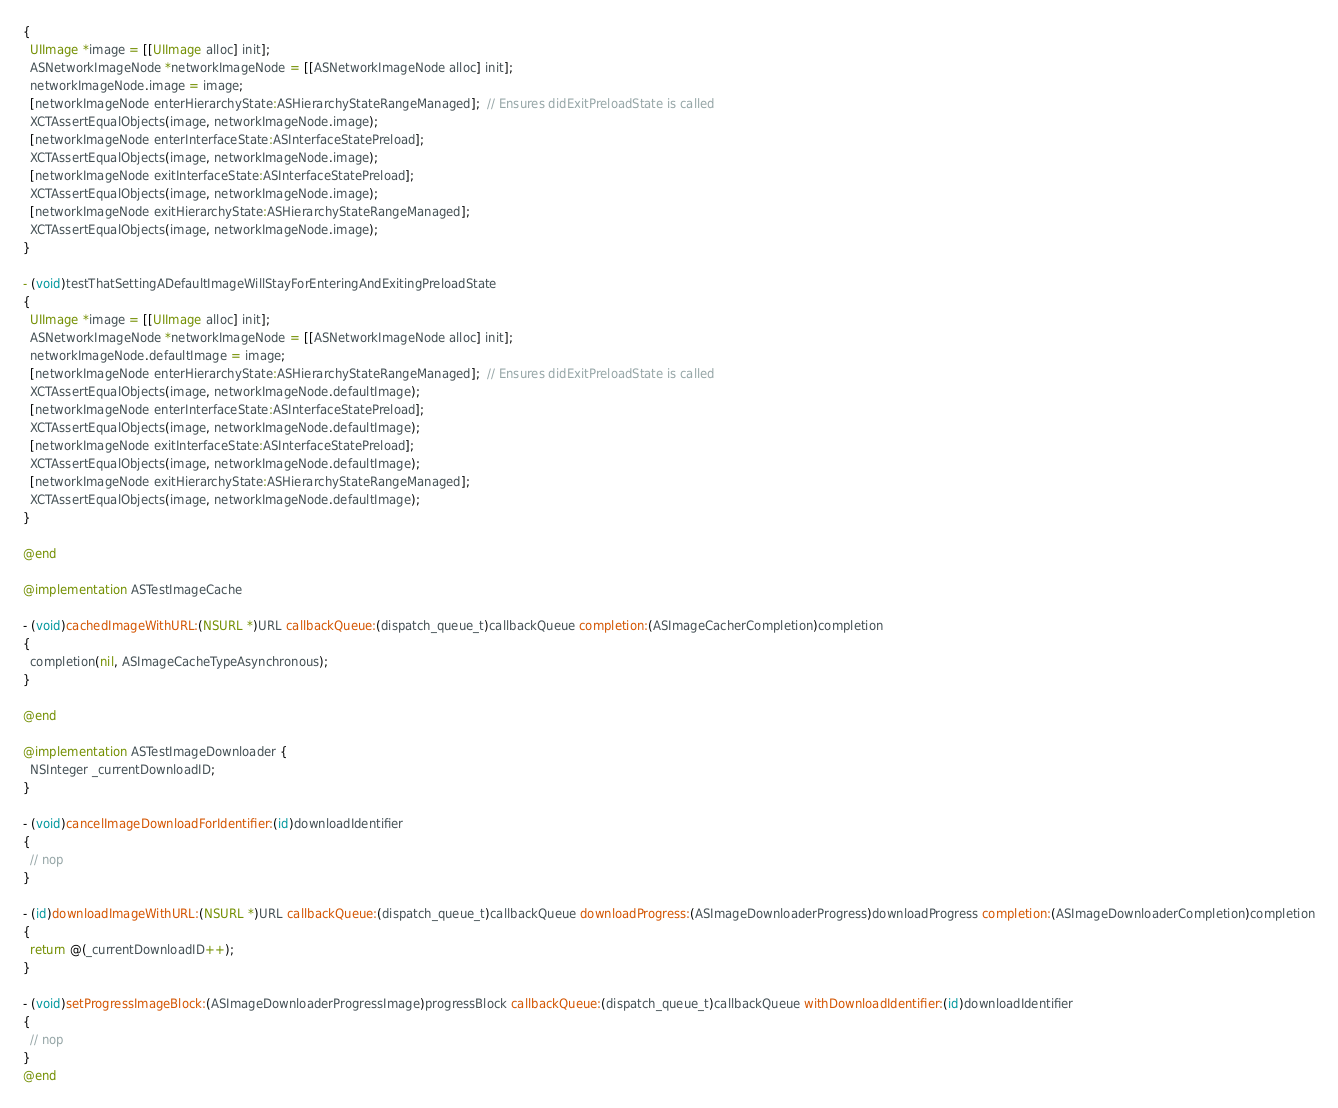<code> <loc_0><loc_0><loc_500><loc_500><_ObjectiveC_>{
  UIImage *image = [[UIImage alloc] init];
  ASNetworkImageNode *networkImageNode = [[ASNetworkImageNode alloc] init];
  networkImageNode.image = image;
  [networkImageNode enterHierarchyState:ASHierarchyStateRangeManaged];  // Ensures didExitPreloadState is called
  XCTAssertEqualObjects(image, networkImageNode.image);
  [networkImageNode enterInterfaceState:ASInterfaceStatePreload];
  XCTAssertEqualObjects(image, networkImageNode.image);
  [networkImageNode exitInterfaceState:ASInterfaceStatePreload];
  XCTAssertEqualObjects(image, networkImageNode.image);
  [networkImageNode exitHierarchyState:ASHierarchyStateRangeManaged];
  XCTAssertEqualObjects(image, networkImageNode.image);
}

- (void)testThatSettingADefaultImageWillStayForEnteringAndExitingPreloadState
{
  UIImage *image = [[UIImage alloc] init];
  ASNetworkImageNode *networkImageNode = [[ASNetworkImageNode alloc] init];
  networkImageNode.defaultImage = image;
  [networkImageNode enterHierarchyState:ASHierarchyStateRangeManaged];  // Ensures didExitPreloadState is called
  XCTAssertEqualObjects(image, networkImageNode.defaultImage);
  [networkImageNode enterInterfaceState:ASInterfaceStatePreload];
  XCTAssertEqualObjects(image, networkImageNode.defaultImage);
  [networkImageNode exitInterfaceState:ASInterfaceStatePreload];
  XCTAssertEqualObjects(image, networkImageNode.defaultImage);
  [networkImageNode exitHierarchyState:ASHierarchyStateRangeManaged];
  XCTAssertEqualObjects(image, networkImageNode.defaultImage);
}

@end

@implementation ASTestImageCache

- (void)cachedImageWithURL:(NSURL *)URL callbackQueue:(dispatch_queue_t)callbackQueue completion:(ASImageCacherCompletion)completion
{
  completion(nil, ASImageCacheTypeAsynchronous);
}

@end

@implementation ASTestImageDownloader {
  NSInteger _currentDownloadID;
}

- (void)cancelImageDownloadForIdentifier:(id)downloadIdentifier
{
  // nop
}

- (id)downloadImageWithURL:(NSURL *)URL callbackQueue:(dispatch_queue_t)callbackQueue downloadProgress:(ASImageDownloaderProgress)downloadProgress completion:(ASImageDownloaderCompletion)completion
{
  return @(_currentDownloadID++);
}

- (void)setProgressImageBlock:(ASImageDownloaderProgressImage)progressBlock callbackQueue:(dispatch_queue_t)callbackQueue withDownloadIdentifier:(id)downloadIdentifier
{
  // nop
}
@end
</code> 